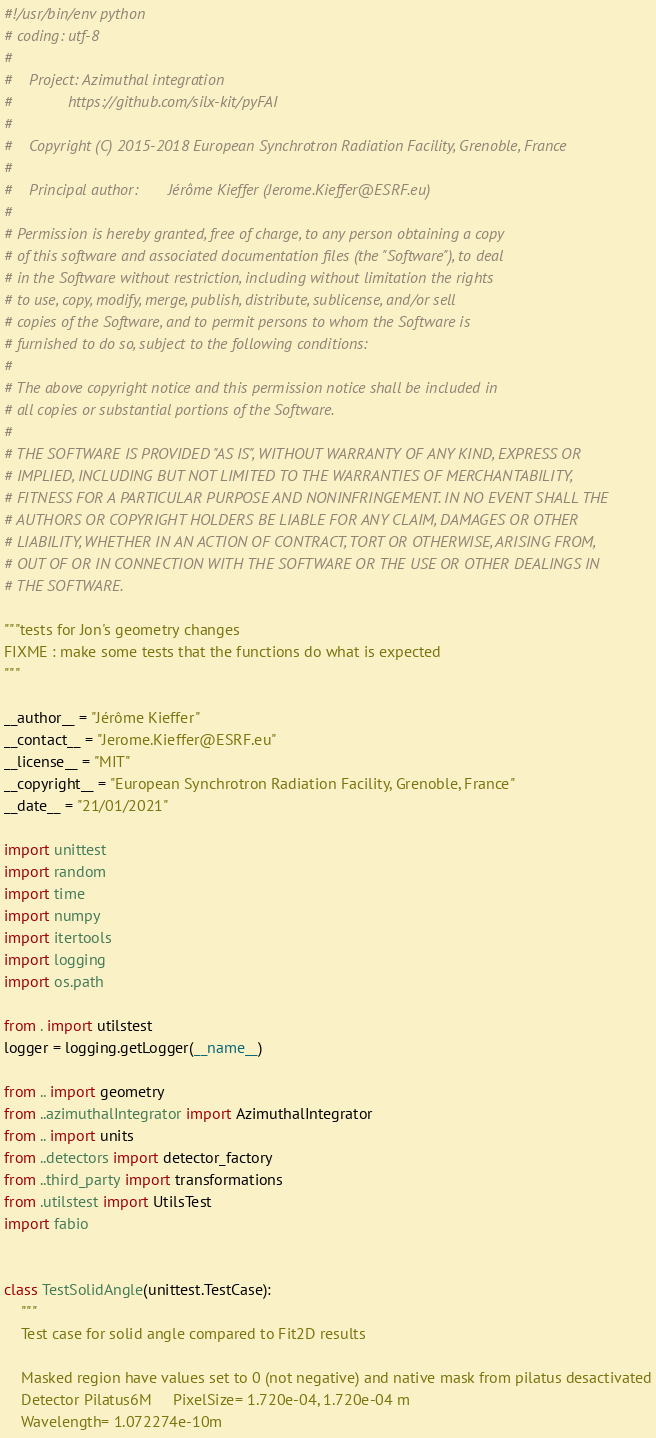Convert code to text. <code><loc_0><loc_0><loc_500><loc_500><_Python_>#!/usr/bin/env python
# coding: utf-8
#
#    Project: Azimuthal integration
#             https://github.com/silx-kit/pyFAI
#
#    Copyright (C) 2015-2018 European Synchrotron Radiation Facility, Grenoble, France
#
#    Principal author:       Jérôme Kieffer (Jerome.Kieffer@ESRF.eu)
#
# Permission is hereby granted, free of charge, to any person obtaining a copy
# of this software and associated documentation files (the "Software"), to deal
# in the Software without restriction, including without limitation the rights
# to use, copy, modify, merge, publish, distribute, sublicense, and/or sell
# copies of the Software, and to permit persons to whom the Software is
# furnished to do so, subject to the following conditions:
#
# The above copyright notice and this permission notice shall be included in
# all copies or substantial portions of the Software.
#
# THE SOFTWARE IS PROVIDED "AS IS", WITHOUT WARRANTY OF ANY KIND, EXPRESS OR
# IMPLIED, INCLUDING BUT NOT LIMITED TO THE WARRANTIES OF MERCHANTABILITY,
# FITNESS FOR A PARTICULAR PURPOSE AND NONINFRINGEMENT. IN NO EVENT SHALL THE
# AUTHORS OR COPYRIGHT HOLDERS BE LIABLE FOR ANY CLAIM, DAMAGES OR OTHER
# LIABILITY, WHETHER IN AN ACTION OF CONTRACT, TORT OR OTHERWISE, ARISING FROM,
# OUT OF OR IN CONNECTION WITH THE SOFTWARE OR THE USE OR OTHER DEALINGS IN
# THE SOFTWARE.

"""tests for Jon's geometry changes
FIXME : make some tests that the functions do what is expected
"""

__author__ = "Jérôme Kieffer"
__contact__ = "Jerome.Kieffer@ESRF.eu"
__license__ = "MIT"
__copyright__ = "European Synchrotron Radiation Facility, Grenoble, France"
__date__ = "21/01/2021"

import unittest
import random
import time
import numpy
import itertools
import logging
import os.path

from . import utilstest
logger = logging.getLogger(__name__)

from .. import geometry
from ..azimuthalIntegrator import AzimuthalIntegrator
from .. import units
from ..detectors import detector_factory
from ..third_party import transformations
from .utilstest import UtilsTest
import fabio


class TestSolidAngle(unittest.TestCase):
    """
    Test case for solid angle compared to Fit2D results

    Masked region have values set to 0 (not negative) and native mask from pilatus desactivated
    Detector Pilatus6M     PixelSize= 1.720e-04, 1.720e-04 m
    Wavelength= 1.072274e-10m</code> 